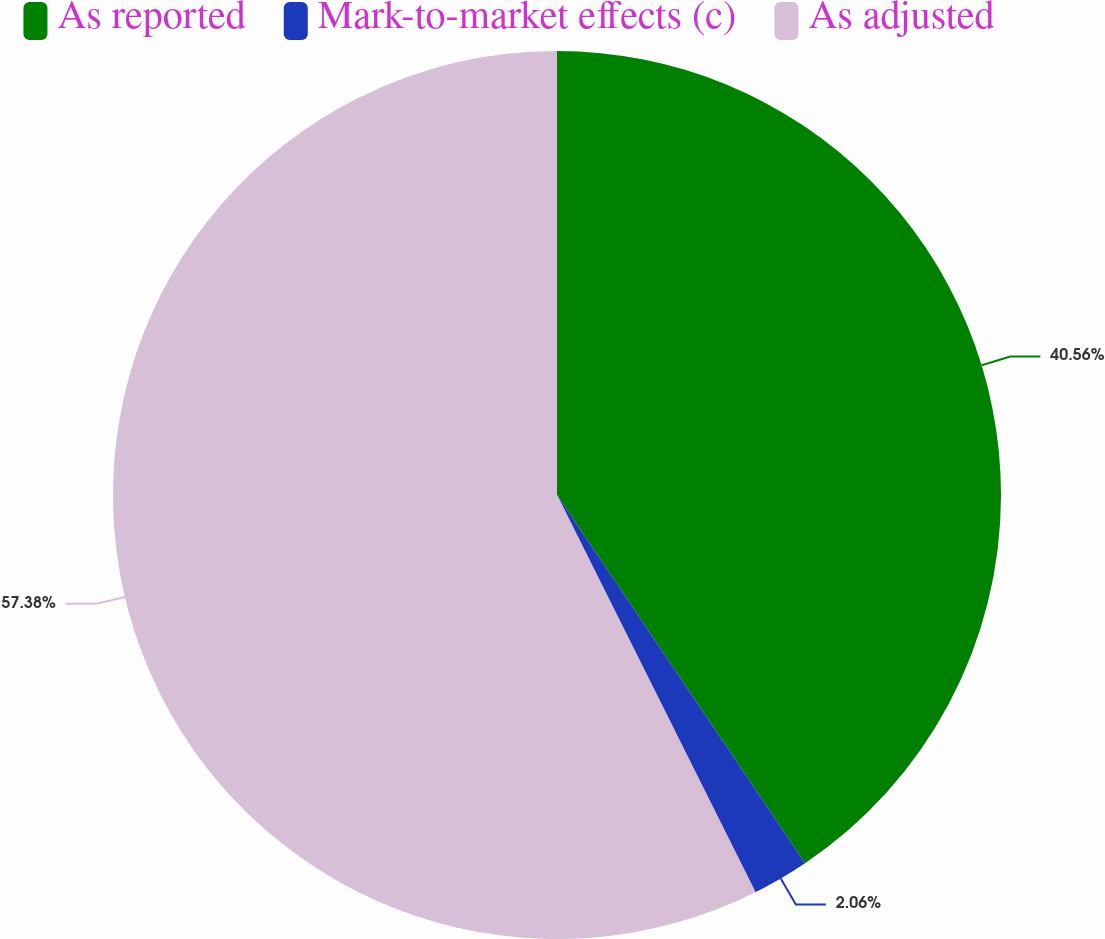Convert chart. <chart><loc_0><loc_0><loc_500><loc_500><pie_chart><fcel>As reported<fcel>Mark-to-market effects (c)<fcel>As adjusted<nl><fcel>40.56%<fcel>2.06%<fcel>57.37%<nl></chart> 